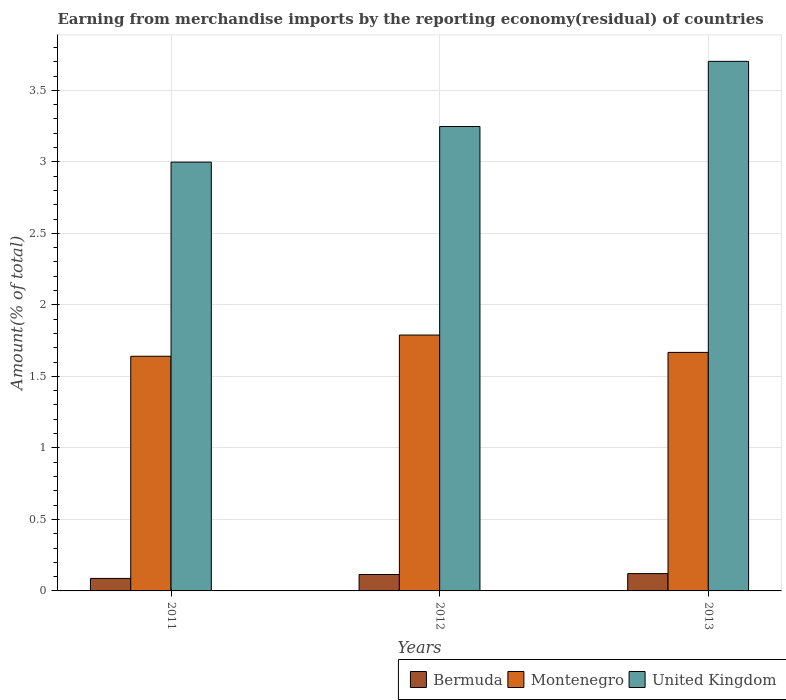Are the number of bars per tick equal to the number of legend labels?
Provide a short and direct response. Yes. Are the number of bars on each tick of the X-axis equal?
Give a very brief answer. Yes. In how many cases, is the number of bars for a given year not equal to the number of legend labels?
Offer a very short reply. 0. What is the percentage of amount earned from merchandise imports in United Kingdom in 2011?
Offer a very short reply. 3. Across all years, what is the maximum percentage of amount earned from merchandise imports in Montenegro?
Offer a terse response. 1.79. Across all years, what is the minimum percentage of amount earned from merchandise imports in Montenegro?
Your answer should be compact. 1.64. In which year was the percentage of amount earned from merchandise imports in United Kingdom maximum?
Your answer should be very brief. 2013. What is the total percentage of amount earned from merchandise imports in United Kingdom in the graph?
Provide a succinct answer. 9.95. What is the difference between the percentage of amount earned from merchandise imports in Bermuda in 2011 and that in 2013?
Keep it short and to the point. -0.03. What is the difference between the percentage of amount earned from merchandise imports in Bermuda in 2011 and the percentage of amount earned from merchandise imports in Montenegro in 2012?
Your answer should be compact. -1.7. What is the average percentage of amount earned from merchandise imports in Montenegro per year?
Make the answer very short. 1.7. In the year 2013, what is the difference between the percentage of amount earned from merchandise imports in United Kingdom and percentage of amount earned from merchandise imports in Montenegro?
Give a very brief answer. 2.03. In how many years, is the percentage of amount earned from merchandise imports in United Kingdom greater than 0.8 %?
Offer a very short reply. 3. What is the ratio of the percentage of amount earned from merchandise imports in United Kingdom in 2011 to that in 2012?
Ensure brevity in your answer.  0.92. Is the percentage of amount earned from merchandise imports in Bermuda in 2012 less than that in 2013?
Keep it short and to the point. Yes. Is the difference between the percentage of amount earned from merchandise imports in United Kingdom in 2012 and 2013 greater than the difference between the percentage of amount earned from merchandise imports in Montenegro in 2012 and 2013?
Offer a very short reply. No. What is the difference between the highest and the second highest percentage of amount earned from merchandise imports in Bermuda?
Give a very brief answer. 0.01. What is the difference between the highest and the lowest percentage of amount earned from merchandise imports in Montenegro?
Provide a short and direct response. 0.15. Is the sum of the percentage of amount earned from merchandise imports in United Kingdom in 2011 and 2013 greater than the maximum percentage of amount earned from merchandise imports in Montenegro across all years?
Make the answer very short. Yes. What does the 1st bar from the left in 2011 represents?
Your answer should be very brief. Bermuda. What does the 2nd bar from the right in 2012 represents?
Your answer should be compact. Montenegro. What is the difference between two consecutive major ticks on the Y-axis?
Your answer should be compact. 0.5. Are the values on the major ticks of Y-axis written in scientific E-notation?
Your answer should be compact. No. Does the graph contain any zero values?
Make the answer very short. No. Does the graph contain grids?
Offer a terse response. Yes. Where does the legend appear in the graph?
Your answer should be very brief. Bottom right. How many legend labels are there?
Keep it short and to the point. 3. How are the legend labels stacked?
Your response must be concise. Horizontal. What is the title of the graph?
Offer a terse response. Earning from merchandise imports by the reporting economy(residual) of countries. Does "Israel" appear as one of the legend labels in the graph?
Provide a short and direct response. No. What is the label or title of the X-axis?
Provide a succinct answer. Years. What is the label or title of the Y-axis?
Keep it short and to the point. Amount(% of total). What is the Amount(% of total) of Bermuda in 2011?
Keep it short and to the point. 0.09. What is the Amount(% of total) of Montenegro in 2011?
Your answer should be compact. 1.64. What is the Amount(% of total) in United Kingdom in 2011?
Keep it short and to the point. 3. What is the Amount(% of total) in Bermuda in 2012?
Your answer should be very brief. 0.11. What is the Amount(% of total) of Montenegro in 2012?
Ensure brevity in your answer.  1.79. What is the Amount(% of total) of United Kingdom in 2012?
Provide a succinct answer. 3.25. What is the Amount(% of total) in Bermuda in 2013?
Give a very brief answer. 0.12. What is the Amount(% of total) of Montenegro in 2013?
Provide a short and direct response. 1.67. What is the Amount(% of total) in United Kingdom in 2013?
Offer a terse response. 3.7. Across all years, what is the maximum Amount(% of total) in Bermuda?
Provide a short and direct response. 0.12. Across all years, what is the maximum Amount(% of total) in Montenegro?
Your answer should be compact. 1.79. Across all years, what is the maximum Amount(% of total) of United Kingdom?
Give a very brief answer. 3.7. Across all years, what is the minimum Amount(% of total) in Bermuda?
Provide a succinct answer. 0.09. Across all years, what is the minimum Amount(% of total) in Montenegro?
Ensure brevity in your answer.  1.64. Across all years, what is the minimum Amount(% of total) in United Kingdom?
Make the answer very short. 3. What is the total Amount(% of total) of Bermuda in the graph?
Your response must be concise. 0.32. What is the total Amount(% of total) in Montenegro in the graph?
Make the answer very short. 5.1. What is the total Amount(% of total) of United Kingdom in the graph?
Ensure brevity in your answer.  9.95. What is the difference between the Amount(% of total) in Bermuda in 2011 and that in 2012?
Keep it short and to the point. -0.03. What is the difference between the Amount(% of total) of Montenegro in 2011 and that in 2012?
Offer a very short reply. -0.15. What is the difference between the Amount(% of total) in United Kingdom in 2011 and that in 2012?
Provide a succinct answer. -0.25. What is the difference between the Amount(% of total) of Bermuda in 2011 and that in 2013?
Give a very brief answer. -0.03. What is the difference between the Amount(% of total) in Montenegro in 2011 and that in 2013?
Your answer should be compact. -0.03. What is the difference between the Amount(% of total) in United Kingdom in 2011 and that in 2013?
Offer a terse response. -0.7. What is the difference between the Amount(% of total) of Bermuda in 2012 and that in 2013?
Keep it short and to the point. -0.01. What is the difference between the Amount(% of total) of Montenegro in 2012 and that in 2013?
Ensure brevity in your answer.  0.12. What is the difference between the Amount(% of total) in United Kingdom in 2012 and that in 2013?
Your response must be concise. -0.46. What is the difference between the Amount(% of total) in Bermuda in 2011 and the Amount(% of total) in Montenegro in 2012?
Give a very brief answer. -1.7. What is the difference between the Amount(% of total) in Bermuda in 2011 and the Amount(% of total) in United Kingdom in 2012?
Provide a succinct answer. -3.16. What is the difference between the Amount(% of total) in Montenegro in 2011 and the Amount(% of total) in United Kingdom in 2012?
Ensure brevity in your answer.  -1.61. What is the difference between the Amount(% of total) in Bermuda in 2011 and the Amount(% of total) in Montenegro in 2013?
Your response must be concise. -1.58. What is the difference between the Amount(% of total) of Bermuda in 2011 and the Amount(% of total) of United Kingdom in 2013?
Offer a terse response. -3.62. What is the difference between the Amount(% of total) of Montenegro in 2011 and the Amount(% of total) of United Kingdom in 2013?
Provide a short and direct response. -2.06. What is the difference between the Amount(% of total) in Bermuda in 2012 and the Amount(% of total) in Montenegro in 2013?
Provide a short and direct response. -1.55. What is the difference between the Amount(% of total) of Bermuda in 2012 and the Amount(% of total) of United Kingdom in 2013?
Offer a very short reply. -3.59. What is the difference between the Amount(% of total) of Montenegro in 2012 and the Amount(% of total) of United Kingdom in 2013?
Make the answer very short. -1.91. What is the average Amount(% of total) of Bermuda per year?
Offer a very short reply. 0.11. What is the average Amount(% of total) of Montenegro per year?
Provide a succinct answer. 1.7. What is the average Amount(% of total) in United Kingdom per year?
Ensure brevity in your answer.  3.32. In the year 2011, what is the difference between the Amount(% of total) in Bermuda and Amount(% of total) in Montenegro?
Your answer should be very brief. -1.55. In the year 2011, what is the difference between the Amount(% of total) in Bermuda and Amount(% of total) in United Kingdom?
Offer a terse response. -2.91. In the year 2011, what is the difference between the Amount(% of total) of Montenegro and Amount(% of total) of United Kingdom?
Make the answer very short. -1.36. In the year 2012, what is the difference between the Amount(% of total) of Bermuda and Amount(% of total) of Montenegro?
Make the answer very short. -1.67. In the year 2012, what is the difference between the Amount(% of total) in Bermuda and Amount(% of total) in United Kingdom?
Your response must be concise. -3.13. In the year 2012, what is the difference between the Amount(% of total) of Montenegro and Amount(% of total) of United Kingdom?
Your answer should be very brief. -1.46. In the year 2013, what is the difference between the Amount(% of total) of Bermuda and Amount(% of total) of Montenegro?
Give a very brief answer. -1.55. In the year 2013, what is the difference between the Amount(% of total) in Bermuda and Amount(% of total) in United Kingdom?
Offer a terse response. -3.58. In the year 2013, what is the difference between the Amount(% of total) in Montenegro and Amount(% of total) in United Kingdom?
Offer a terse response. -2.03. What is the ratio of the Amount(% of total) in Bermuda in 2011 to that in 2012?
Keep it short and to the point. 0.76. What is the ratio of the Amount(% of total) in Montenegro in 2011 to that in 2012?
Your answer should be compact. 0.92. What is the ratio of the Amount(% of total) in United Kingdom in 2011 to that in 2012?
Your answer should be compact. 0.92. What is the ratio of the Amount(% of total) in Bermuda in 2011 to that in 2013?
Provide a succinct answer. 0.72. What is the ratio of the Amount(% of total) in Montenegro in 2011 to that in 2013?
Offer a terse response. 0.98. What is the ratio of the Amount(% of total) of United Kingdom in 2011 to that in 2013?
Give a very brief answer. 0.81. What is the ratio of the Amount(% of total) of Bermuda in 2012 to that in 2013?
Your answer should be compact. 0.95. What is the ratio of the Amount(% of total) of Montenegro in 2012 to that in 2013?
Provide a short and direct response. 1.07. What is the ratio of the Amount(% of total) of United Kingdom in 2012 to that in 2013?
Make the answer very short. 0.88. What is the difference between the highest and the second highest Amount(% of total) of Bermuda?
Your answer should be compact. 0.01. What is the difference between the highest and the second highest Amount(% of total) of Montenegro?
Ensure brevity in your answer.  0.12. What is the difference between the highest and the second highest Amount(% of total) in United Kingdom?
Provide a short and direct response. 0.46. What is the difference between the highest and the lowest Amount(% of total) of Bermuda?
Give a very brief answer. 0.03. What is the difference between the highest and the lowest Amount(% of total) of Montenegro?
Your response must be concise. 0.15. What is the difference between the highest and the lowest Amount(% of total) of United Kingdom?
Offer a very short reply. 0.7. 